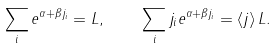Convert formula to latex. <formula><loc_0><loc_0><loc_500><loc_500>\sum _ { i } e ^ { \alpha + \beta j _ { i } } = L , \quad \sum _ { i } j _ { i } e ^ { \alpha + \beta j _ { i } } = \langle j \rangle \, L .</formula> 